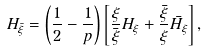<formula> <loc_0><loc_0><loc_500><loc_500>H _ { \bar { \xi } } = \left ( \frac { 1 } { 2 } - \frac { 1 } { p } \right ) \left [ \frac { \xi } { \bar { \xi } } H _ { \xi } + \frac { \bar { \xi } } { \xi } \bar { H _ { \xi } } \right ] ,</formula> 